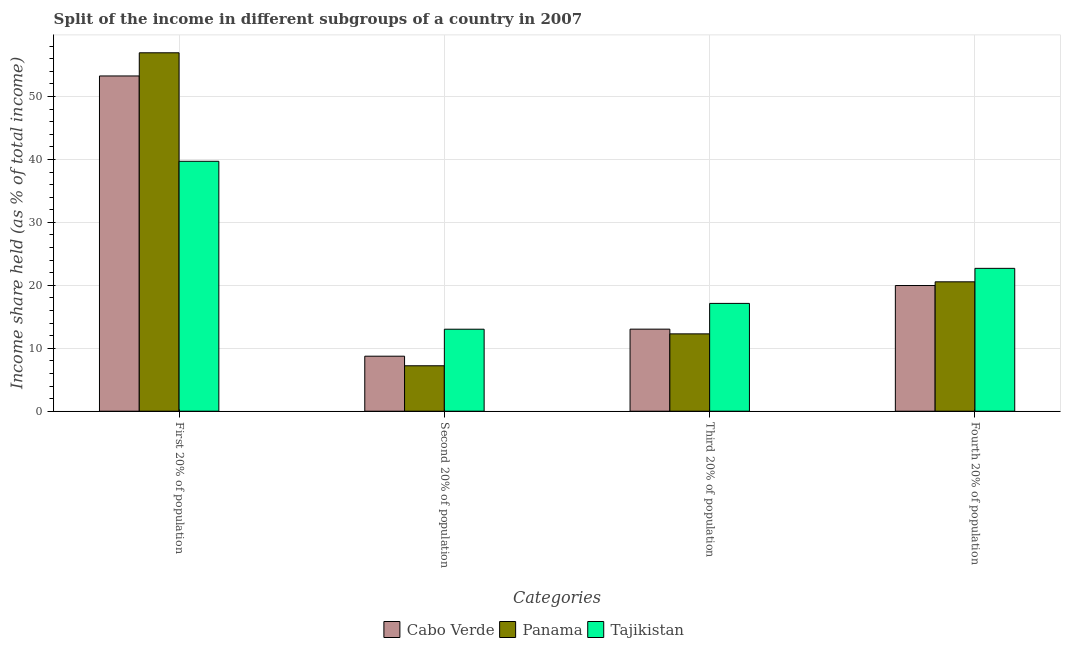Are the number of bars on each tick of the X-axis equal?
Give a very brief answer. Yes. What is the label of the 3rd group of bars from the left?
Your answer should be very brief. Third 20% of population. What is the share of the income held by third 20% of the population in Tajikistan?
Keep it short and to the point. 17.13. Across all countries, what is the maximum share of the income held by first 20% of the population?
Your answer should be very brief. 56.95. Across all countries, what is the minimum share of the income held by fourth 20% of the population?
Provide a short and direct response. 19.97. In which country was the share of the income held by third 20% of the population maximum?
Keep it short and to the point. Tajikistan. In which country was the share of the income held by second 20% of the population minimum?
Provide a succinct answer. Panama. What is the total share of the income held by third 20% of the population in the graph?
Provide a succinct answer. 42.46. What is the difference between the share of the income held by fourth 20% of the population in Panama and that in Cabo Verde?
Provide a short and direct response. 0.59. What is the difference between the share of the income held by first 20% of the population in Cabo Verde and the share of the income held by second 20% of the population in Tajikistan?
Offer a very short reply. 40.24. What is the average share of the income held by fourth 20% of the population per country?
Make the answer very short. 21.08. What is the difference between the share of the income held by first 20% of the population and share of the income held by third 20% of the population in Cabo Verde?
Your answer should be compact. 40.23. What is the ratio of the share of the income held by third 20% of the population in Tajikistan to that in Cabo Verde?
Your answer should be very brief. 1.31. Is the share of the income held by second 20% of the population in Panama less than that in Tajikistan?
Your answer should be very brief. Yes. What is the difference between the highest and the second highest share of the income held by second 20% of the population?
Your response must be concise. 4.29. What is the difference between the highest and the lowest share of the income held by second 20% of the population?
Your answer should be compact. 5.81. In how many countries, is the share of the income held by second 20% of the population greater than the average share of the income held by second 20% of the population taken over all countries?
Ensure brevity in your answer.  1. What does the 2nd bar from the left in First 20% of population represents?
Your answer should be compact. Panama. What does the 2nd bar from the right in Second 20% of population represents?
Give a very brief answer. Panama. Does the graph contain any zero values?
Your answer should be compact. No. What is the title of the graph?
Your answer should be very brief. Split of the income in different subgroups of a country in 2007. Does "Sint Maarten (Dutch part)" appear as one of the legend labels in the graph?
Keep it short and to the point. No. What is the label or title of the X-axis?
Offer a very short reply. Categories. What is the label or title of the Y-axis?
Ensure brevity in your answer.  Income share held (as % of total income). What is the Income share held (as % of total income) of Cabo Verde in First 20% of population?
Provide a short and direct response. 53.27. What is the Income share held (as % of total income) in Panama in First 20% of population?
Offer a very short reply. 56.95. What is the Income share held (as % of total income) in Tajikistan in First 20% of population?
Offer a very short reply. 39.71. What is the Income share held (as % of total income) in Cabo Verde in Second 20% of population?
Provide a succinct answer. 8.74. What is the Income share held (as % of total income) of Panama in Second 20% of population?
Offer a terse response. 7.22. What is the Income share held (as % of total income) of Tajikistan in Second 20% of population?
Your answer should be very brief. 13.03. What is the Income share held (as % of total income) in Cabo Verde in Third 20% of population?
Provide a short and direct response. 13.04. What is the Income share held (as % of total income) of Panama in Third 20% of population?
Give a very brief answer. 12.29. What is the Income share held (as % of total income) in Tajikistan in Third 20% of population?
Your answer should be compact. 17.13. What is the Income share held (as % of total income) in Cabo Verde in Fourth 20% of population?
Make the answer very short. 19.97. What is the Income share held (as % of total income) in Panama in Fourth 20% of population?
Offer a terse response. 20.56. What is the Income share held (as % of total income) in Tajikistan in Fourth 20% of population?
Provide a succinct answer. 22.7. Across all Categories, what is the maximum Income share held (as % of total income) of Cabo Verde?
Offer a terse response. 53.27. Across all Categories, what is the maximum Income share held (as % of total income) in Panama?
Provide a short and direct response. 56.95. Across all Categories, what is the maximum Income share held (as % of total income) in Tajikistan?
Offer a terse response. 39.71. Across all Categories, what is the minimum Income share held (as % of total income) of Cabo Verde?
Ensure brevity in your answer.  8.74. Across all Categories, what is the minimum Income share held (as % of total income) in Panama?
Ensure brevity in your answer.  7.22. Across all Categories, what is the minimum Income share held (as % of total income) in Tajikistan?
Your answer should be very brief. 13.03. What is the total Income share held (as % of total income) in Cabo Verde in the graph?
Your response must be concise. 95.02. What is the total Income share held (as % of total income) in Panama in the graph?
Your response must be concise. 97.02. What is the total Income share held (as % of total income) of Tajikistan in the graph?
Offer a terse response. 92.57. What is the difference between the Income share held (as % of total income) in Cabo Verde in First 20% of population and that in Second 20% of population?
Keep it short and to the point. 44.53. What is the difference between the Income share held (as % of total income) of Panama in First 20% of population and that in Second 20% of population?
Provide a succinct answer. 49.73. What is the difference between the Income share held (as % of total income) of Tajikistan in First 20% of population and that in Second 20% of population?
Your response must be concise. 26.68. What is the difference between the Income share held (as % of total income) of Cabo Verde in First 20% of population and that in Third 20% of population?
Offer a very short reply. 40.23. What is the difference between the Income share held (as % of total income) in Panama in First 20% of population and that in Third 20% of population?
Provide a short and direct response. 44.66. What is the difference between the Income share held (as % of total income) of Tajikistan in First 20% of population and that in Third 20% of population?
Provide a short and direct response. 22.58. What is the difference between the Income share held (as % of total income) in Cabo Verde in First 20% of population and that in Fourth 20% of population?
Make the answer very short. 33.3. What is the difference between the Income share held (as % of total income) of Panama in First 20% of population and that in Fourth 20% of population?
Your response must be concise. 36.39. What is the difference between the Income share held (as % of total income) of Tajikistan in First 20% of population and that in Fourth 20% of population?
Ensure brevity in your answer.  17.01. What is the difference between the Income share held (as % of total income) in Panama in Second 20% of population and that in Third 20% of population?
Offer a terse response. -5.07. What is the difference between the Income share held (as % of total income) of Tajikistan in Second 20% of population and that in Third 20% of population?
Your response must be concise. -4.1. What is the difference between the Income share held (as % of total income) of Cabo Verde in Second 20% of population and that in Fourth 20% of population?
Provide a succinct answer. -11.23. What is the difference between the Income share held (as % of total income) in Panama in Second 20% of population and that in Fourth 20% of population?
Offer a very short reply. -13.34. What is the difference between the Income share held (as % of total income) in Tajikistan in Second 20% of population and that in Fourth 20% of population?
Your response must be concise. -9.67. What is the difference between the Income share held (as % of total income) in Cabo Verde in Third 20% of population and that in Fourth 20% of population?
Provide a succinct answer. -6.93. What is the difference between the Income share held (as % of total income) in Panama in Third 20% of population and that in Fourth 20% of population?
Offer a very short reply. -8.27. What is the difference between the Income share held (as % of total income) in Tajikistan in Third 20% of population and that in Fourth 20% of population?
Ensure brevity in your answer.  -5.57. What is the difference between the Income share held (as % of total income) in Cabo Verde in First 20% of population and the Income share held (as % of total income) in Panama in Second 20% of population?
Offer a terse response. 46.05. What is the difference between the Income share held (as % of total income) in Cabo Verde in First 20% of population and the Income share held (as % of total income) in Tajikistan in Second 20% of population?
Make the answer very short. 40.24. What is the difference between the Income share held (as % of total income) of Panama in First 20% of population and the Income share held (as % of total income) of Tajikistan in Second 20% of population?
Offer a very short reply. 43.92. What is the difference between the Income share held (as % of total income) of Cabo Verde in First 20% of population and the Income share held (as % of total income) of Panama in Third 20% of population?
Make the answer very short. 40.98. What is the difference between the Income share held (as % of total income) of Cabo Verde in First 20% of population and the Income share held (as % of total income) of Tajikistan in Third 20% of population?
Your answer should be compact. 36.14. What is the difference between the Income share held (as % of total income) in Panama in First 20% of population and the Income share held (as % of total income) in Tajikistan in Third 20% of population?
Make the answer very short. 39.82. What is the difference between the Income share held (as % of total income) of Cabo Verde in First 20% of population and the Income share held (as % of total income) of Panama in Fourth 20% of population?
Offer a very short reply. 32.71. What is the difference between the Income share held (as % of total income) of Cabo Verde in First 20% of population and the Income share held (as % of total income) of Tajikistan in Fourth 20% of population?
Your answer should be very brief. 30.57. What is the difference between the Income share held (as % of total income) of Panama in First 20% of population and the Income share held (as % of total income) of Tajikistan in Fourth 20% of population?
Your answer should be compact. 34.25. What is the difference between the Income share held (as % of total income) of Cabo Verde in Second 20% of population and the Income share held (as % of total income) of Panama in Third 20% of population?
Your answer should be compact. -3.55. What is the difference between the Income share held (as % of total income) in Cabo Verde in Second 20% of population and the Income share held (as % of total income) in Tajikistan in Third 20% of population?
Make the answer very short. -8.39. What is the difference between the Income share held (as % of total income) in Panama in Second 20% of population and the Income share held (as % of total income) in Tajikistan in Third 20% of population?
Your response must be concise. -9.91. What is the difference between the Income share held (as % of total income) in Cabo Verde in Second 20% of population and the Income share held (as % of total income) in Panama in Fourth 20% of population?
Provide a succinct answer. -11.82. What is the difference between the Income share held (as % of total income) of Cabo Verde in Second 20% of population and the Income share held (as % of total income) of Tajikistan in Fourth 20% of population?
Keep it short and to the point. -13.96. What is the difference between the Income share held (as % of total income) in Panama in Second 20% of population and the Income share held (as % of total income) in Tajikistan in Fourth 20% of population?
Provide a succinct answer. -15.48. What is the difference between the Income share held (as % of total income) in Cabo Verde in Third 20% of population and the Income share held (as % of total income) in Panama in Fourth 20% of population?
Offer a very short reply. -7.52. What is the difference between the Income share held (as % of total income) in Cabo Verde in Third 20% of population and the Income share held (as % of total income) in Tajikistan in Fourth 20% of population?
Ensure brevity in your answer.  -9.66. What is the difference between the Income share held (as % of total income) in Panama in Third 20% of population and the Income share held (as % of total income) in Tajikistan in Fourth 20% of population?
Your response must be concise. -10.41. What is the average Income share held (as % of total income) in Cabo Verde per Categories?
Ensure brevity in your answer.  23.75. What is the average Income share held (as % of total income) of Panama per Categories?
Give a very brief answer. 24.25. What is the average Income share held (as % of total income) of Tajikistan per Categories?
Offer a terse response. 23.14. What is the difference between the Income share held (as % of total income) of Cabo Verde and Income share held (as % of total income) of Panama in First 20% of population?
Provide a succinct answer. -3.68. What is the difference between the Income share held (as % of total income) in Cabo Verde and Income share held (as % of total income) in Tajikistan in First 20% of population?
Make the answer very short. 13.56. What is the difference between the Income share held (as % of total income) of Panama and Income share held (as % of total income) of Tajikistan in First 20% of population?
Give a very brief answer. 17.24. What is the difference between the Income share held (as % of total income) in Cabo Verde and Income share held (as % of total income) in Panama in Second 20% of population?
Give a very brief answer. 1.52. What is the difference between the Income share held (as % of total income) of Cabo Verde and Income share held (as % of total income) of Tajikistan in Second 20% of population?
Offer a terse response. -4.29. What is the difference between the Income share held (as % of total income) in Panama and Income share held (as % of total income) in Tajikistan in Second 20% of population?
Provide a succinct answer. -5.81. What is the difference between the Income share held (as % of total income) of Cabo Verde and Income share held (as % of total income) of Panama in Third 20% of population?
Offer a very short reply. 0.75. What is the difference between the Income share held (as % of total income) in Cabo Verde and Income share held (as % of total income) in Tajikistan in Third 20% of population?
Ensure brevity in your answer.  -4.09. What is the difference between the Income share held (as % of total income) in Panama and Income share held (as % of total income) in Tajikistan in Third 20% of population?
Your answer should be very brief. -4.84. What is the difference between the Income share held (as % of total income) in Cabo Verde and Income share held (as % of total income) in Panama in Fourth 20% of population?
Make the answer very short. -0.59. What is the difference between the Income share held (as % of total income) of Cabo Verde and Income share held (as % of total income) of Tajikistan in Fourth 20% of population?
Ensure brevity in your answer.  -2.73. What is the difference between the Income share held (as % of total income) in Panama and Income share held (as % of total income) in Tajikistan in Fourth 20% of population?
Your answer should be compact. -2.14. What is the ratio of the Income share held (as % of total income) in Cabo Verde in First 20% of population to that in Second 20% of population?
Give a very brief answer. 6.09. What is the ratio of the Income share held (as % of total income) of Panama in First 20% of population to that in Second 20% of population?
Provide a short and direct response. 7.89. What is the ratio of the Income share held (as % of total income) in Tajikistan in First 20% of population to that in Second 20% of population?
Give a very brief answer. 3.05. What is the ratio of the Income share held (as % of total income) of Cabo Verde in First 20% of population to that in Third 20% of population?
Ensure brevity in your answer.  4.09. What is the ratio of the Income share held (as % of total income) in Panama in First 20% of population to that in Third 20% of population?
Your answer should be compact. 4.63. What is the ratio of the Income share held (as % of total income) in Tajikistan in First 20% of population to that in Third 20% of population?
Give a very brief answer. 2.32. What is the ratio of the Income share held (as % of total income) in Cabo Verde in First 20% of population to that in Fourth 20% of population?
Your response must be concise. 2.67. What is the ratio of the Income share held (as % of total income) in Panama in First 20% of population to that in Fourth 20% of population?
Provide a succinct answer. 2.77. What is the ratio of the Income share held (as % of total income) in Tajikistan in First 20% of population to that in Fourth 20% of population?
Provide a succinct answer. 1.75. What is the ratio of the Income share held (as % of total income) of Cabo Verde in Second 20% of population to that in Third 20% of population?
Provide a succinct answer. 0.67. What is the ratio of the Income share held (as % of total income) in Panama in Second 20% of population to that in Third 20% of population?
Your answer should be very brief. 0.59. What is the ratio of the Income share held (as % of total income) in Tajikistan in Second 20% of population to that in Third 20% of population?
Provide a short and direct response. 0.76. What is the ratio of the Income share held (as % of total income) of Cabo Verde in Second 20% of population to that in Fourth 20% of population?
Provide a short and direct response. 0.44. What is the ratio of the Income share held (as % of total income) of Panama in Second 20% of population to that in Fourth 20% of population?
Your response must be concise. 0.35. What is the ratio of the Income share held (as % of total income) of Tajikistan in Second 20% of population to that in Fourth 20% of population?
Your answer should be very brief. 0.57. What is the ratio of the Income share held (as % of total income) in Cabo Verde in Third 20% of population to that in Fourth 20% of population?
Offer a terse response. 0.65. What is the ratio of the Income share held (as % of total income) in Panama in Third 20% of population to that in Fourth 20% of population?
Offer a very short reply. 0.6. What is the ratio of the Income share held (as % of total income) of Tajikistan in Third 20% of population to that in Fourth 20% of population?
Give a very brief answer. 0.75. What is the difference between the highest and the second highest Income share held (as % of total income) in Cabo Verde?
Ensure brevity in your answer.  33.3. What is the difference between the highest and the second highest Income share held (as % of total income) in Panama?
Offer a very short reply. 36.39. What is the difference between the highest and the second highest Income share held (as % of total income) in Tajikistan?
Your response must be concise. 17.01. What is the difference between the highest and the lowest Income share held (as % of total income) in Cabo Verde?
Give a very brief answer. 44.53. What is the difference between the highest and the lowest Income share held (as % of total income) in Panama?
Offer a very short reply. 49.73. What is the difference between the highest and the lowest Income share held (as % of total income) in Tajikistan?
Your answer should be compact. 26.68. 